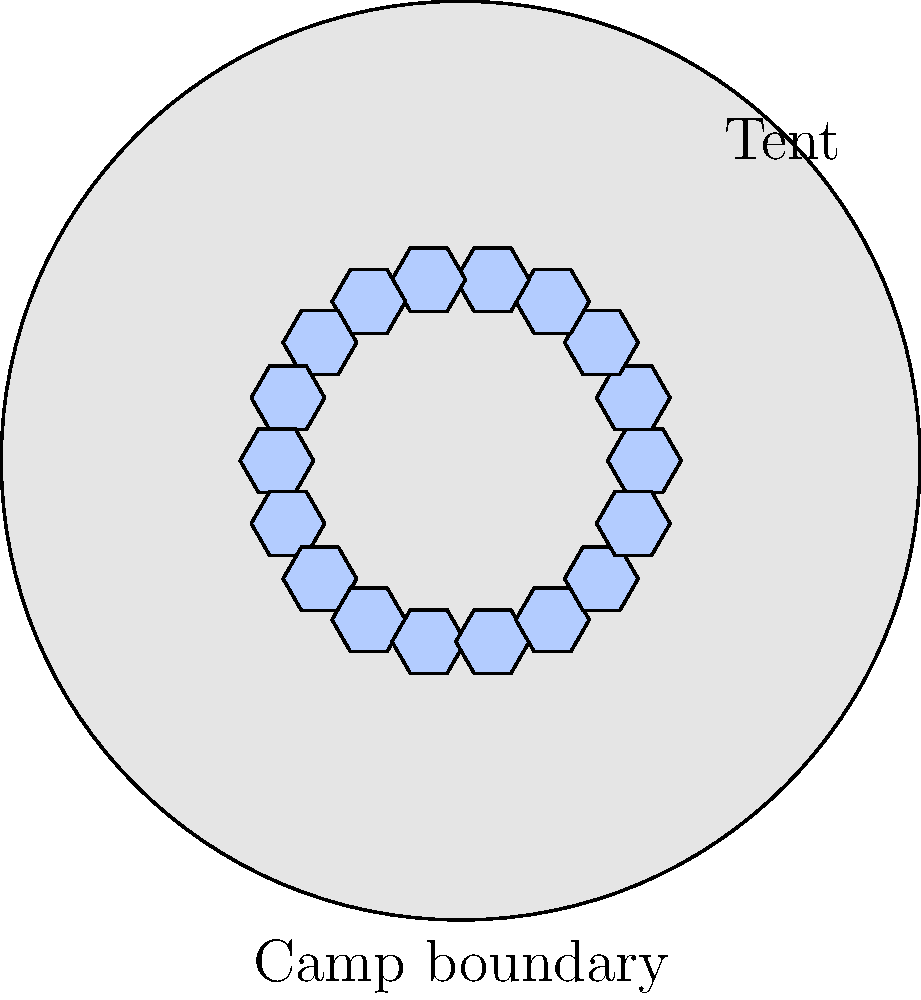In a circular refugee camp with a radius of 50 meters, hexagonal tents are arranged in a specific pattern. Each tent has a side length of 2 meters. If the tents are placed in concentric rings with 6 tents in the innermost ring, 12 in the second ring, and 18 in the third ring, what is the maximum number of complete rings of tents that can fit within the camp boundary? Let's approach this step-by-step:

1) First, we need to calculate the area of each hexagonal tent:
   Area of a hexagon = $\frac{3\sqrt{3}}{2}s^2$, where $s$ is the side length
   Area = $\frac{3\sqrt{3}}{2}(2^2) = 6\sqrt{3}$ square meters

2) Now, let's calculate the number of tents in each ring:
   1st ring: 6 tents
   2nd ring: 12 tents
   3rd ring: 18 tents
   We can see that each ring increases by 6 tents

3) So, the number of tents in the nth ring would be $6n$

4) The total number of tents up to the nth ring would be:
   $6 + 12 + 18 + ... + 6n = 6(1 + 2 + 3 + ... + n) = 6 \cdot \frac{n(n+1)}{2} = 3n(n+1)$

5) The area occupied by these tents would be:
   $3n(n+1) \cdot 6\sqrt{3} = 18\sqrt{3}n(n+1)$ square meters

6) The area of the circular camp is:
   $\pi r^2 = \pi (50^2) = 2500\pi$ square meters

7) To find the maximum number of complete rings, we need to solve:
   $18\sqrt{3}n(n+1) \leq 2500\pi$

8) Solving this inequality:
   $n^2 + n - \frac{2500\pi}{18\sqrt{3}} \leq 0$
   $n^2 + n - 83.8 \leq 0$
   $n \leq 8.7$

9) Since we need complete rings, the maximum number of rings is 8.
Answer: 8 rings 